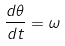Convert formula to latex. <formula><loc_0><loc_0><loc_500><loc_500>\frac { d \theta } { d t } = \omega</formula> 